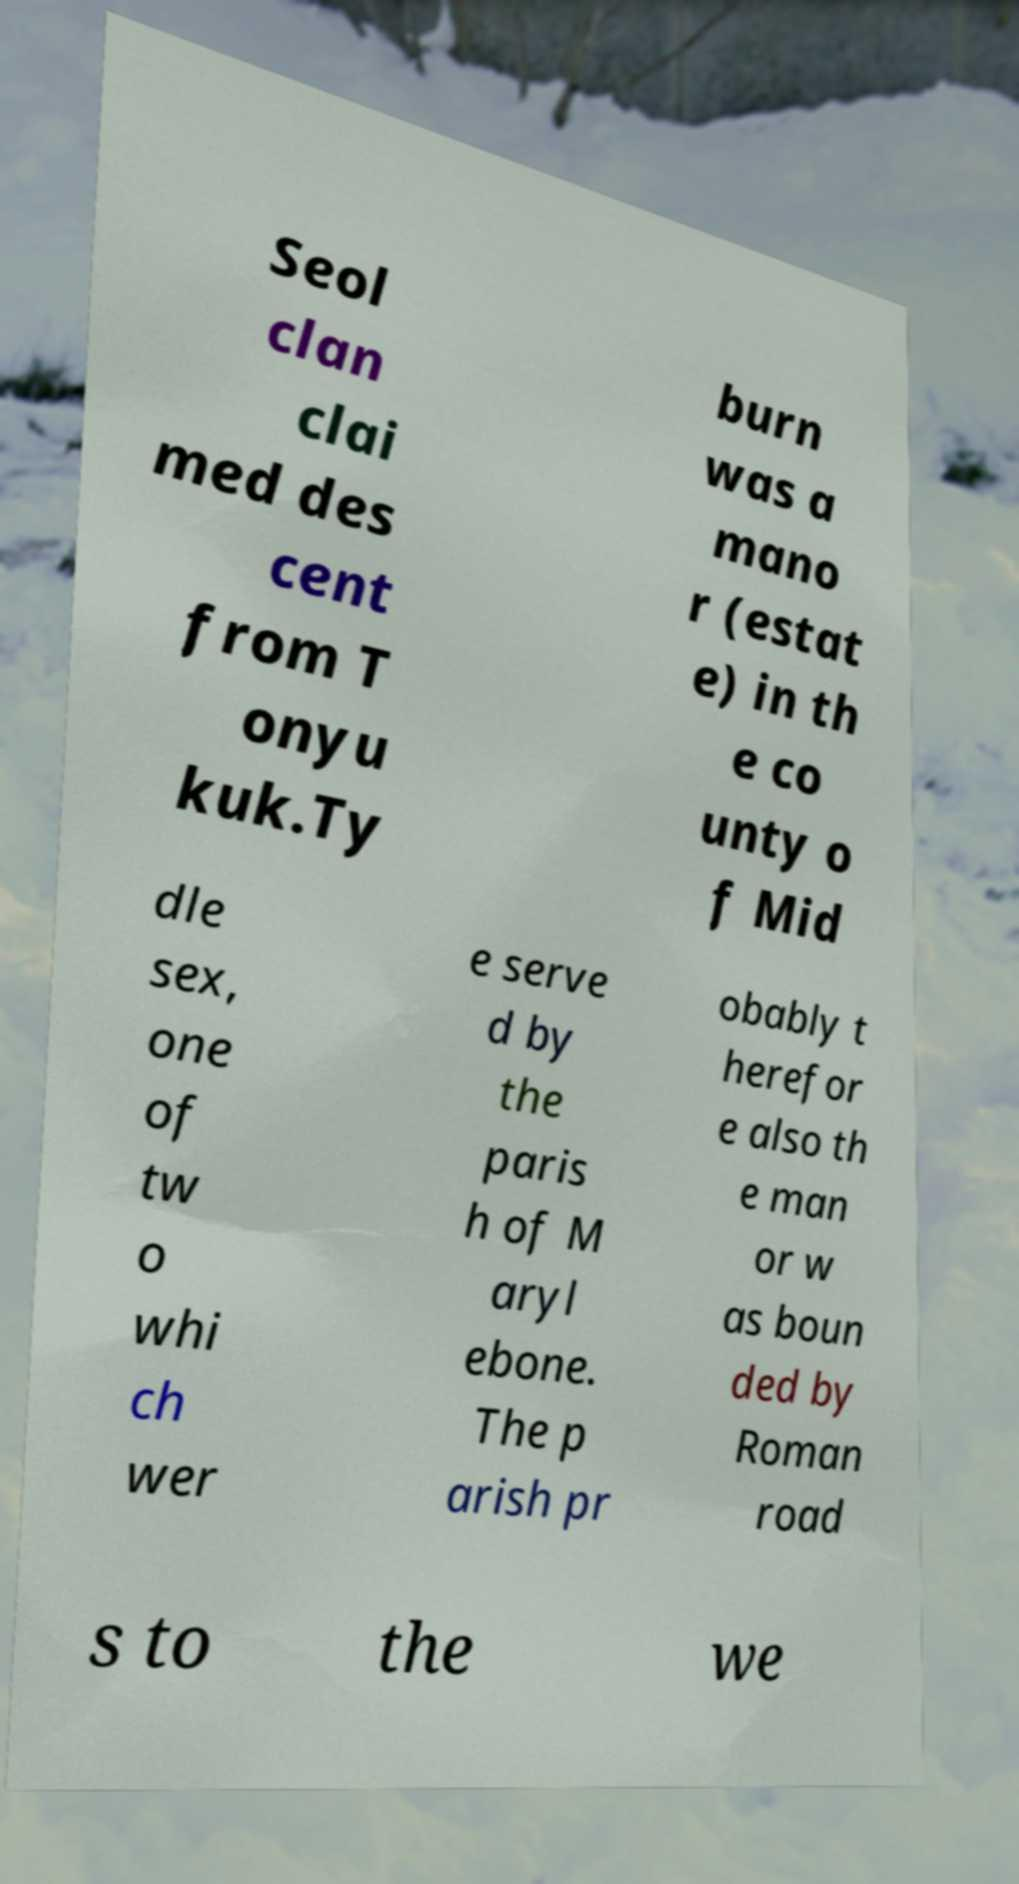Please identify and transcribe the text found in this image. Seol clan clai med des cent from T onyu kuk.Ty burn was a mano r (estat e) in th e co unty o f Mid dle sex, one of tw o whi ch wer e serve d by the paris h of M aryl ebone. The p arish pr obably t herefor e also th e man or w as boun ded by Roman road s to the we 